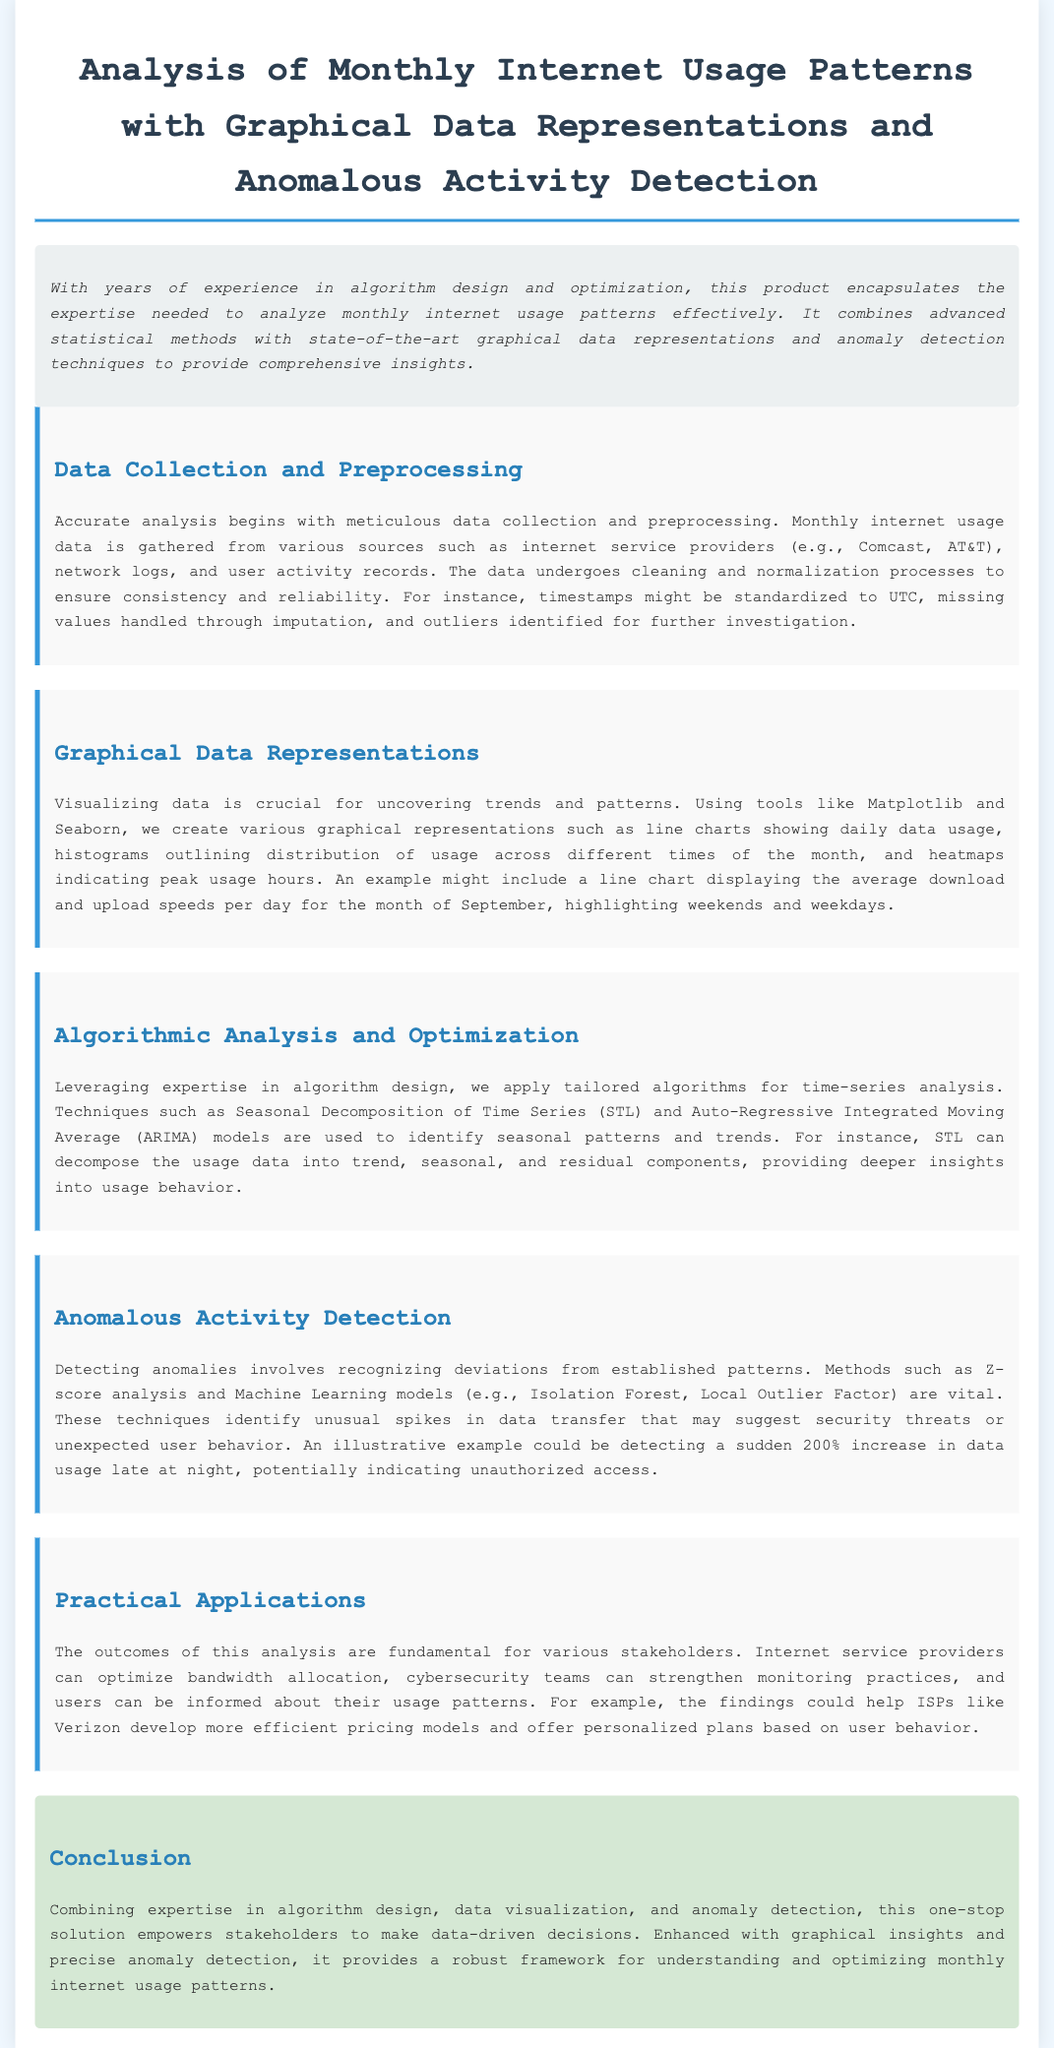what is the title of the document? The title is located in the header section of the document, which clearly states the focus of the analysis.
Answer: Analysis of Monthly Internet Usage Patterns with Graphical Data Representations and Anomalous Activity Detection what tools are mentioned for graphical representations? The document specifies tools that are used for visualizing data, which are highlighted in the section discussing graphical data representations.
Answer: Matplotlib and Seaborn what method is used to detect anomalies? In the section on anomalous activity detection, several techniques are mentioned as essential for identifying deviations in data usage patterns.
Answer: Z-score analysis and Machine Learning models what is the main application for internet service providers? The practical applications section outlines how the findings from the analysis can benefit internet service providers in a specific manner.
Answer: Optimize bandwidth allocation what algorithm is used in time-series analysis? The document describes specific techniques employed for analyzing time-series data under the algorithmic analysis section.
Answer: ARIMA models which month is used for the example line chart? The reference to an example line chart in the text indicates the specific month used for graphical analysis.
Answer: September what type of analysis combines statistical methods and graphical representations? The introduction presents the overarching approach utilized throughout the document, focusing on combining various analytical techniques.
Answer: Comprehensive insights what is a consequence of a sudden 200% increase in data usage? The document explains the implications of unusual spikes in activity as seen in the anomalous activity detection section.
Answer: Unauthorized access 